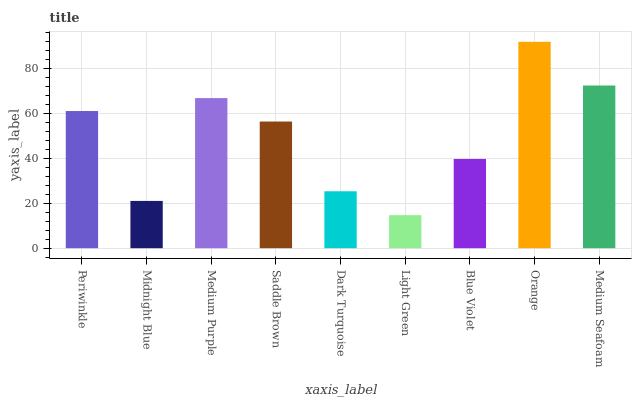Is Light Green the minimum?
Answer yes or no. Yes. Is Orange the maximum?
Answer yes or no. Yes. Is Midnight Blue the minimum?
Answer yes or no. No. Is Midnight Blue the maximum?
Answer yes or no. No. Is Periwinkle greater than Midnight Blue?
Answer yes or no. Yes. Is Midnight Blue less than Periwinkle?
Answer yes or no. Yes. Is Midnight Blue greater than Periwinkle?
Answer yes or no. No. Is Periwinkle less than Midnight Blue?
Answer yes or no. No. Is Saddle Brown the high median?
Answer yes or no. Yes. Is Saddle Brown the low median?
Answer yes or no. Yes. Is Midnight Blue the high median?
Answer yes or no. No. Is Periwinkle the low median?
Answer yes or no. No. 